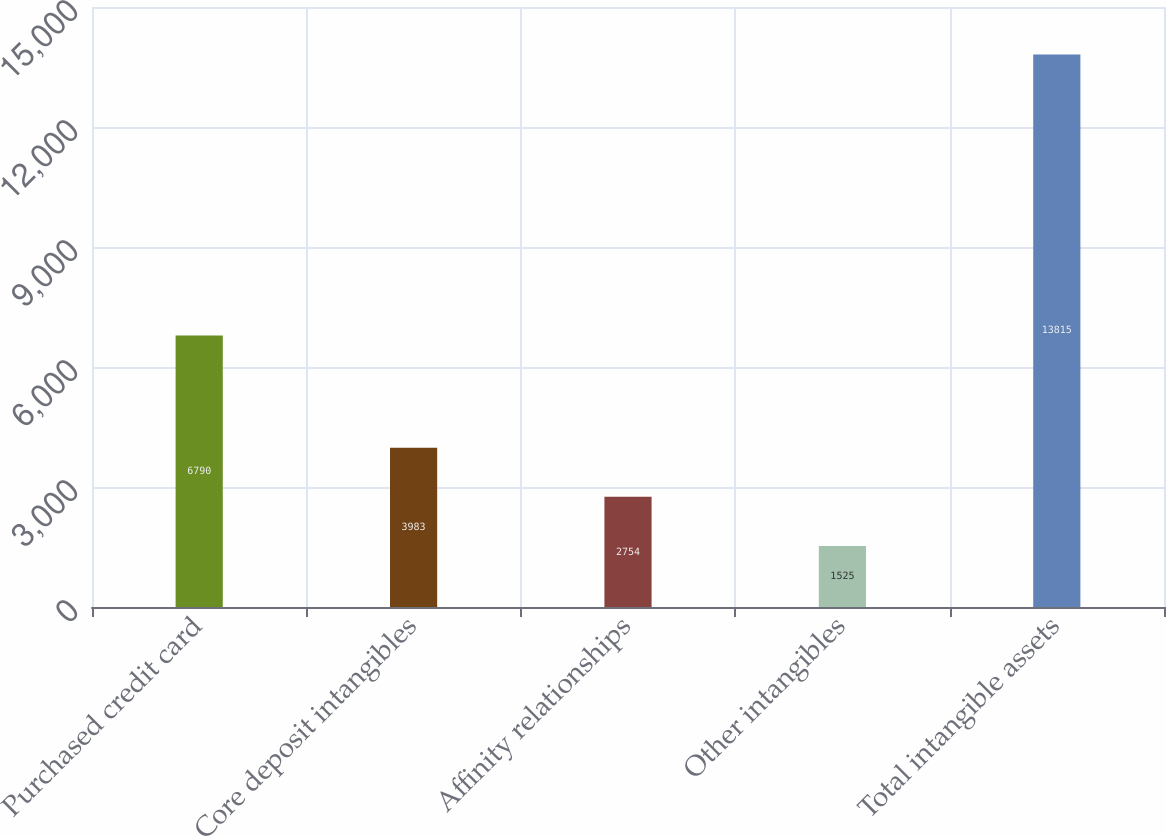Convert chart. <chart><loc_0><loc_0><loc_500><loc_500><bar_chart><fcel>Purchased credit card<fcel>Core deposit intangibles<fcel>Affinity relationships<fcel>Other intangibles<fcel>Total intangible assets<nl><fcel>6790<fcel>3983<fcel>2754<fcel>1525<fcel>13815<nl></chart> 